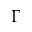Convert formula to latex. <formula><loc_0><loc_0><loc_500><loc_500>\Gamma</formula> 